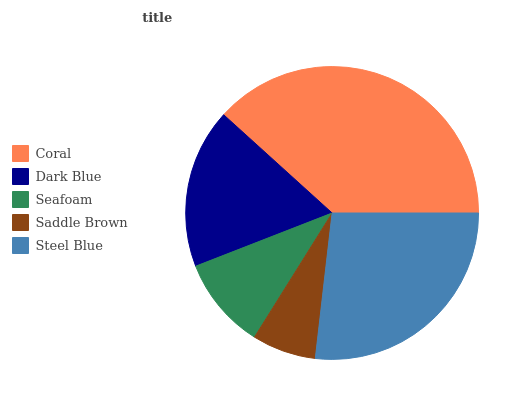Is Saddle Brown the minimum?
Answer yes or no. Yes. Is Coral the maximum?
Answer yes or no. Yes. Is Dark Blue the minimum?
Answer yes or no. No. Is Dark Blue the maximum?
Answer yes or no. No. Is Coral greater than Dark Blue?
Answer yes or no. Yes. Is Dark Blue less than Coral?
Answer yes or no. Yes. Is Dark Blue greater than Coral?
Answer yes or no. No. Is Coral less than Dark Blue?
Answer yes or no. No. Is Dark Blue the high median?
Answer yes or no. Yes. Is Dark Blue the low median?
Answer yes or no. Yes. Is Steel Blue the high median?
Answer yes or no. No. Is Steel Blue the low median?
Answer yes or no. No. 